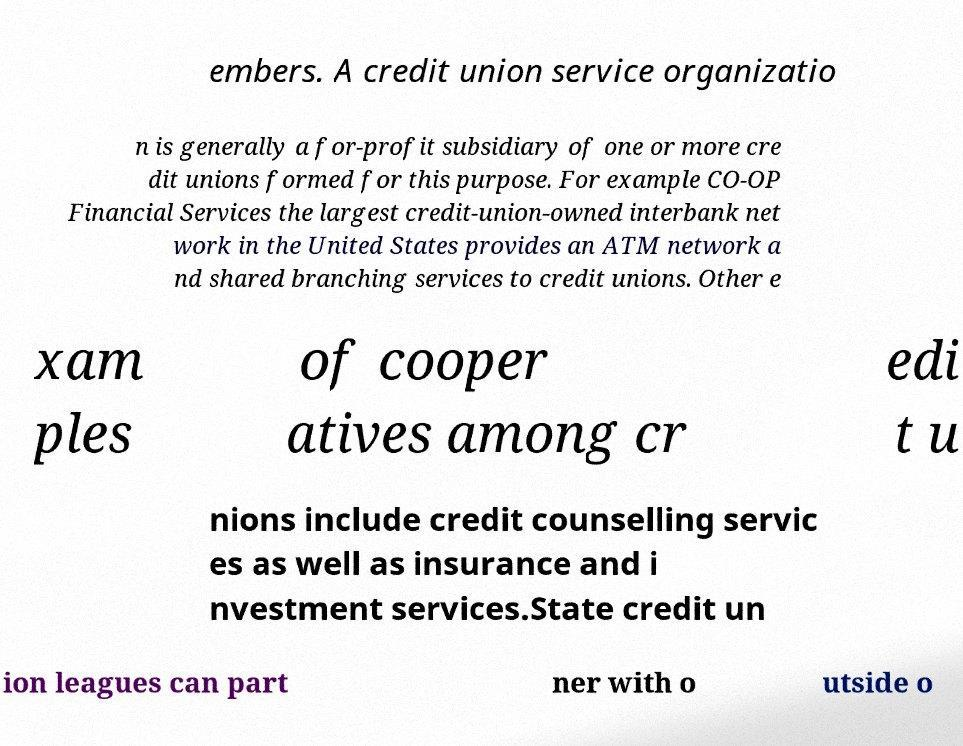There's text embedded in this image that I need extracted. Can you transcribe it verbatim? embers. A credit union service organizatio n is generally a for-profit subsidiary of one or more cre dit unions formed for this purpose. For example CO-OP Financial Services the largest credit-union-owned interbank net work in the United States provides an ATM network a nd shared branching services to credit unions. Other e xam ples of cooper atives among cr edi t u nions include credit counselling servic es as well as insurance and i nvestment services.State credit un ion leagues can part ner with o utside o 